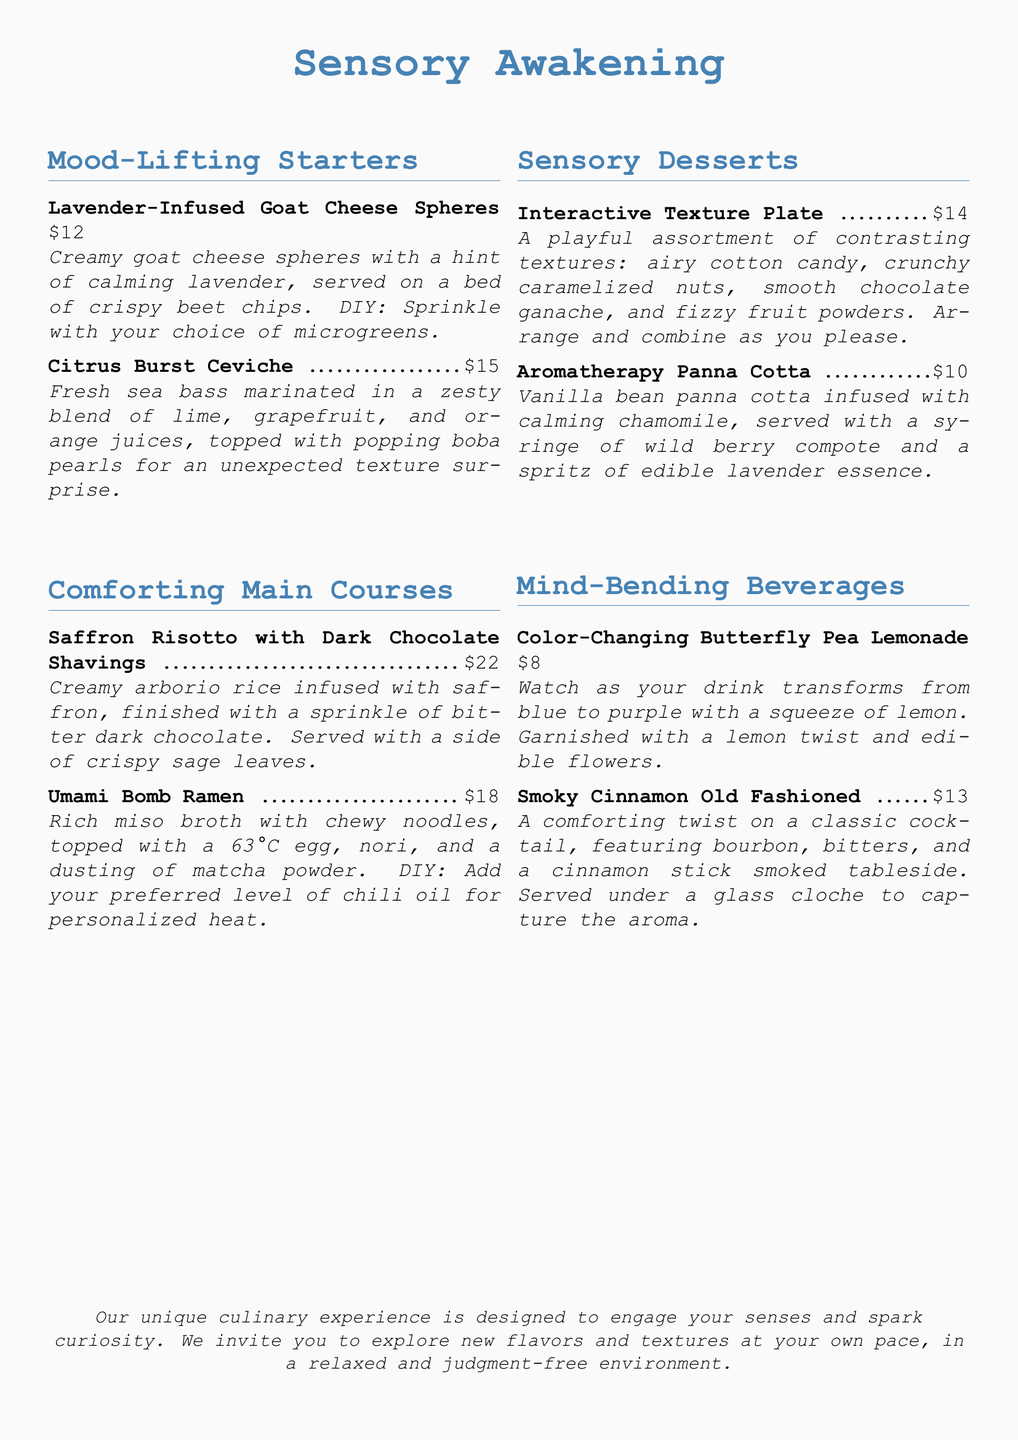What is the price of the Lavender-Infused Goat Cheese Spheres? The price is listed next to the menu item in the document.
Answer: $12 What unique texture is included in the Citrus Burst Ceviche? The document mentions an unexpected texture surprise in the dish.
Answer: Popping boba pearls What is the main ingredient in the Umami Bomb Ramen broth? The main component mentioned in the description is the type of broth used.
Answer: Miso How much does the Interactive Texture Plate cost? The cost is provided for the dessert option in the menu.
Answer: $14 What flavor is infused in the Aromatherapy Panna Cotta? The flavor is part of the dessert's description listed in the menu.
Answer: Chamomile Which beverage changes color with lemon? This is indicated in the beverage section of the menu.
Answer: Butterfly Pea Lemonade What DIY option is available with the Umami Bomb Ramen? The DIY element is described in the main course section.
Answer: Chili oil How many mood-lifting starters are featured in the document? The starters are under the respective section, and their count includes all listed items.
Answer: 2 What type of dessert combines different textures? The dessert is clearly labeled in the menu as an interactive dish.
Answer: Interactive Texture Plate 